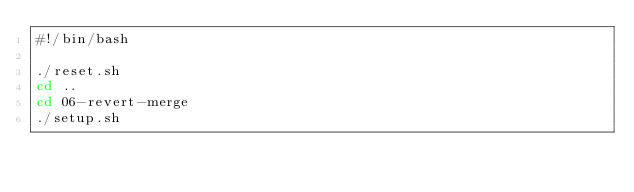Convert code to text. <code><loc_0><loc_0><loc_500><loc_500><_Bash_>#!/bin/bash

./reset.sh
cd ..
cd 06-revert-merge
./setup.sh
</code> 